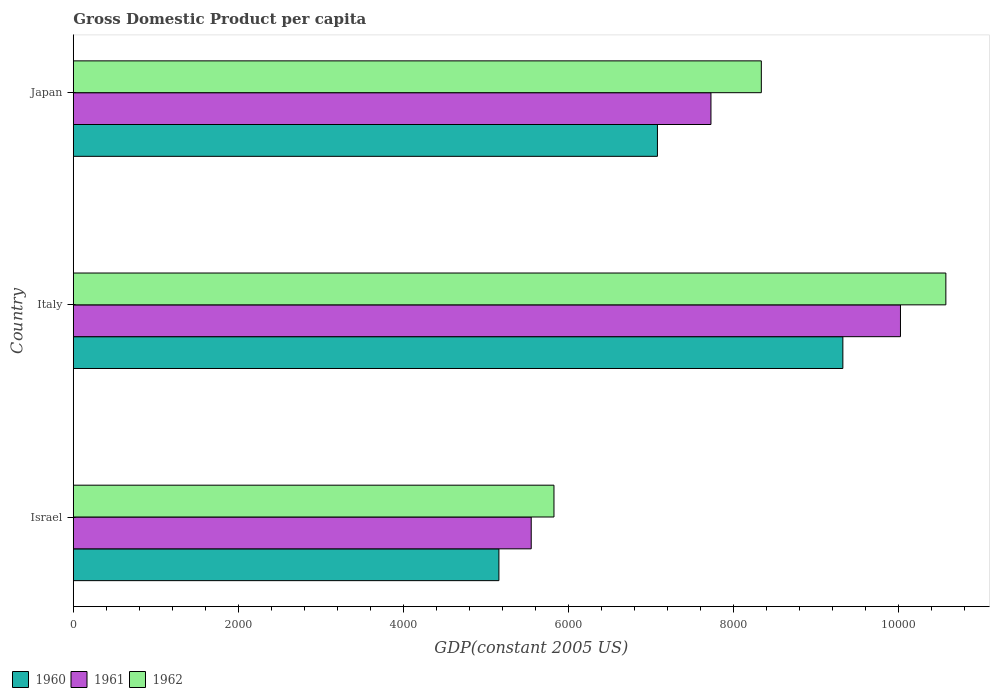How many bars are there on the 2nd tick from the top?
Give a very brief answer. 3. How many bars are there on the 3rd tick from the bottom?
Keep it short and to the point. 3. In how many cases, is the number of bars for a given country not equal to the number of legend labels?
Give a very brief answer. 0. What is the GDP per capita in 1962 in Italy?
Your response must be concise. 1.06e+04. Across all countries, what is the maximum GDP per capita in 1961?
Make the answer very short. 1.00e+04. Across all countries, what is the minimum GDP per capita in 1960?
Your answer should be compact. 5158.09. In which country was the GDP per capita in 1960 maximum?
Your answer should be very brief. Italy. In which country was the GDP per capita in 1961 minimum?
Ensure brevity in your answer.  Israel. What is the total GDP per capita in 1962 in the graph?
Give a very brief answer. 2.47e+04. What is the difference between the GDP per capita in 1960 in Israel and that in Italy?
Keep it short and to the point. -4168.57. What is the difference between the GDP per capita in 1962 in Israel and the GDP per capita in 1961 in Italy?
Your answer should be compact. -4199.53. What is the average GDP per capita in 1961 per country?
Offer a terse response. 7767.51. What is the difference between the GDP per capita in 1962 and GDP per capita in 1961 in Japan?
Offer a terse response. 610.41. In how many countries, is the GDP per capita in 1962 greater than 8400 US$?
Offer a terse response. 1. What is the ratio of the GDP per capita in 1960 in Italy to that in Japan?
Your answer should be very brief. 1.32. Is the GDP per capita in 1961 in Israel less than that in Japan?
Your answer should be compact. Yes. What is the difference between the highest and the second highest GDP per capita in 1962?
Provide a short and direct response. 2236.61. What is the difference between the highest and the lowest GDP per capita in 1962?
Your answer should be compact. 4749.65. Is the sum of the GDP per capita in 1961 in Israel and Japan greater than the maximum GDP per capita in 1960 across all countries?
Your response must be concise. Yes. What does the 3rd bar from the top in Italy represents?
Provide a short and direct response. 1960. What does the 1st bar from the bottom in Israel represents?
Your response must be concise. 1960. What is the difference between two consecutive major ticks on the X-axis?
Offer a terse response. 2000. Are the values on the major ticks of X-axis written in scientific E-notation?
Your answer should be compact. No. Does the graph contain any zero values?
Make the answer very short. No. Where does the legend appear in the graph?
Keep it short and to the point. Bottom left. What is the title of the graph?
Make the answer very short. Gross Domestic Product per capita. What is the label or title of the X-axis?
Make the answer very short. GDP(constant 2005 US). What is the label or title of the Y-axis?
Offer a terse response. Country. What is the GDP(constant 2005 US) of 1960 in Israel?
Give a very brief answer. 5158.09. What is the GDP(constant 2005 US) of 1961 in Israel?
Your answer should be very brief. 5549.66. What is the GDP(constant 2005 US) in 1962 in Israel?
Your answer should be very brief. 5825.36. What is the GDP(constant 2005 US) of 1960 in Italy?
Keep it short and to the point. 9326.66. What is the GDP(constant 2005 US) in 1961 in Italy?
Offer a terse response. 1.00e+04. What is the GDP(constant 2005 US) in 1962 in Italy?
Provide a short and direct response. 1.06e+04. What is the GDP(constant 2005 US) in 1960 in Japan?
Offer a very short reply. 7079.43. What is the GDP(constant 2005 US) in 1961 in Japan?
Give a very brief answer. 7727.99. What is the GDP(constant 2005 US) of 1962 in Japan?
Make the answer very short. 8338.39. Across all countries, what is the maximum GDP(constant 2005 US) of 1960?
Give a very brief answer. 9326.66. Across all countries, what is the maximum GDP(constant 2005 US) of 1961?
Your response must be concise. 1.00e+04. Across all countries, what is the maximum GDP(constant 2005 US) of 1962?
Provide a short and direct response. 1.06e+04. Across all countries, what is the minimum GDP(constant 2005 US) in 1960?
Make the answer very short. 5158.09. Across all countries, what is the minimum GDP(constant 2005 US) in 1961?
Offer a very short reply. 5549.66. Across all countries, what is the minimum GDP(constant 2005 US) in 1962?
Offer a terse response. 5825.36. What is the total GDP(constant 2005 US) of 1960 in the graph?
Offer a very short reply. 2.16e+04. What is the total GDP(constant 2005 US) in 1961 in the graph?
Your answer should be very brief. 2.33e+04. What is the total GDP(constant 2005 US) of 1962 in the graph?
Provide a short and direct response. 2.47e+04. What is the difference between the GDP(constant 2005 US) in 1960 in Israel and that in Italy?
Your response must be concise. -4168.57. What is the difference between the GDP(constant 2005 US) in 1961 in Israel and that in Italy?
Keep it short and to the point. -4475.23. What is the difference between the GDP(constant 2005 US) in 1962 in Israel and that in Italy?
Provide a succinct answer. -4749.65. What is the difference between the GDP(constant 2005 US) of 1960 in Israel and that in Japan?
Keep it short and to the point. -1921.34. What is the difference between the GDP(constant 2005 US) of 1961 in Israel and that in Japan?
Make the answer very short. -2178.32. What is the difference between the GDP(constant 2005 US) of 1962 in Israel and that in Japan?
Make the answer very short. -2513.04. What is the difference between the GDP(constant 2005 US) in 1960 in Italy and that in Japan?
Your response must be concise. 2247.23. What is the difference between the GDP(constant 2005 US) of 1961 in Italy and that in Japan?
Offer a terse response. 2296.9. What is the difference between the GDP(constant 2005 US) of 1962 in Italy and that in Japan?
Provide a succinct answer. 2236.61. What is the difference between the GDP(constant 2005 US) in 1960 in Israel and the GDP(constant 2005 US) in 1961 in Italy?
Keep it short and to the point. -4866.8. What is the difference between the GDP(constant 2005 US) of 1960 in Israel and the GDP(constant 2005 US) of 1962 in Italy?
Your answer should be compact. -5416.91. What is the difference between the GDP(constant 2005 US) of 1961 in Israel and the GDP(constant 2005 US) of 1962 in Italy?
Offer a terse response. -5025.34. What is the difference between the GDP(constant 2005 US) of 1960 in Israel and the GDP(constant 2005 US) of 1961 in Japan?
Ensure brevity in your answer.  -2569.9. What is the difference between the GDP(constant 2005 US) in 1960 in Israel and the GDP(constant 2005 US) in 1962 in Japan?
Offer a terse response. -3180.3. What is the difference between the GDP(constant 2005 US) of 1961 in Israel and the GDP(constant 2005 US) of 1962 in Japan?
Keep it short and to the point. -2788.73. What is the difference between the GDP(constant 2005 US) in 1960 in Italy and the GDP(constant 2005 US) in 1961 in Japan?
Offer a very short reply. 1598.67. What is the difference between the GDP(constant 2005 US) of 1960 in Italy and the GDP(constant 2005 US) of 1962 in Japan?
Give a very brief answer. 988.26. What is the difference between the GDP(constant 2005 US) in 1961 in Italy and the GDP(constant 2005 US) in 1962 in Japan?
Your answer should be very brief. 1686.5. What is the average GDP(constant 2005 US) in 1960 per country?
Provide a short and direct response. 7188.06. What is the average GDP(constant 2005 US) in 1961 per country?
Your answer should be compact. 7767.51. What is the average GDP(constant 2005 US) of 1962 per country?
Ensure brevity in your answer.  8246.25. What is the difference between the GDP(constant 2005 US) of 1960 and GDP(constant 2005 US) of 1961 in Israel?
Offer a very short reply. -391.57. What is the difference between the GDP(constant 2005 US) in 1960 and GDP(constant 2005 US) in 1962 in Israel?
Offer a terse response. -667.27. What is the difference between the GDP(constant 2005 US) in 1961 and GDP(constant 2005 US) in 1962 in Israel?
Ensure brevity in your answer.  -275.69. What is the difference between the GDP(constant 2005 US) in 1960 and GDP(constant 2005 US) in 1961 in Italy?
Ensure brevity in your answer.  -698.23. What is the difference between the GDP(constant 2005 US) in 1960 and GDP(constant 2005 US) in 1962 in Italy?
Offer a terse response. -1248.35. What is the difference between the GDP(constant 2005 US) in 1961 and GDP(constant 2005 US) in 1962 in Italy?
Your response must be concise. -550.11. What is the difference between the GDP(constant 2005 US) in 1960 and GDP(constant 2005 US) in 1961 in Japan?
Ensure brevity in your answer.  -648.56. What is the difference between the GDP(constant 2005 US) of 1960 and GDP(constant 2005 US) of 1962 in Japan?
Ensure brevity in your answer.  -1258.97. What is the difference between the GDP(constant 2005 US) of 1961 and GDP(constant 2005 US) of 1962 in Japan?
Offer a terse response. -610.41. What is the ratio of the GDP(constant 2005 US) in 1960 in Israel to that in Italy?
Keep it short and to the point. 0.55. What is the ratio of the GDP(constant 2005 US) in 1961 in Israel to that in Italy?
Offer a terse response. 0.55. What is the ratio of the GDP(constant 2005 US) in 1962 in Israel to that in Italy?
Your answer should be compact. 0.55. What is the ratio of the GDP(constant 2005 US) of 1960 in Israel to that in Japan?
Offer a very short reply. 0.73. What is the ratio of the GDP(constant 2005 US) of 1961 in Israel to that in Japan?
Ensure brevity in your answer.  0.72. What is the ratio of the GDP(constant 2005 US) of 1962 in Israel to that in Japan?
Keep it short and to the point. 0.7. What is the ratio of the GDP(constant 2005 US) of 1960 in Italy to that in Japan?
Provide a succinct answer. 1.32. What is the ratio of the GDP(constant 2005 US) of 1961 in Italy to that in Japan?
Your response must be concise. 1.3. What is the ratio of the GDP(constant 2005 US) of 1962 in Italy to that in Japan?
Ensure brevity in your answer.  1.27. What is the difference between the highest and the second highest GDP(constant 2005 US) in 1960?
Keep it short and to the point. 2247.23. What is the difference between the highest and the second highest GDP(constant 2005 US) of 1961?
Provide a succinct answer. 2296.9. What is the difference between the highest and the second highest GDP(constant 2005 US) in 1962?
Give a very brief answer. 2236.61. What is the difference between the highest and the lowest GDP(constant 2005 US) of 1960?
Your answer should be very brief. 4168.57. What is the difference between the highest and the lowest GDP(constant 2005 US) in 1961?
Offer a terse response. 4475.23. What is the difference between the highest and the lowest GDP(constant 2005 US) of 1962?
Offer a terse response. 4749.65. 